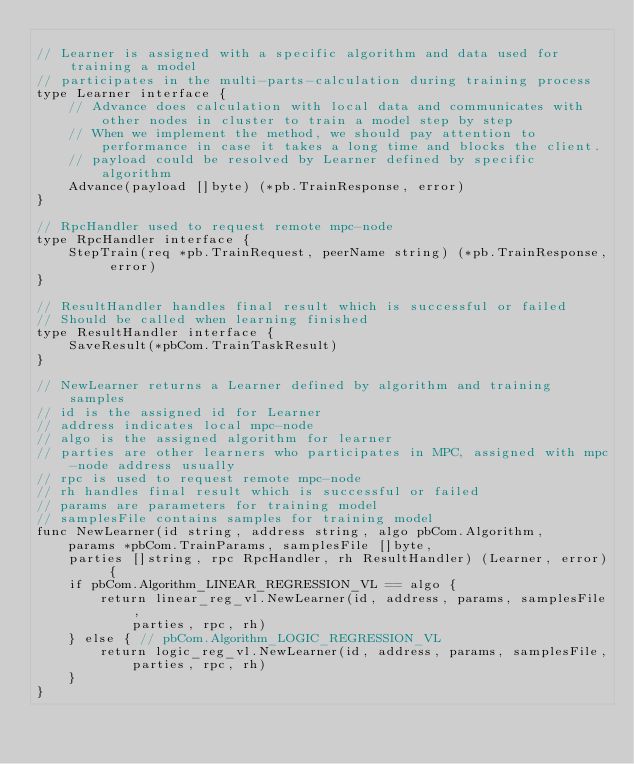<code> <loc_0><loc_0><loc_500><loc_500><_Go_>
// Learner is assigned with a specific algorithm and data used for training a model
// participates in the multi-parts-calculation during training process
type Learner interface {
	// Advance does calculation with local data and communicates with other nodes in cluster to train a model step by step
	// When we implement the method, we should pay attention to performance in case it takes a long time and blocks the client.
	// payload could be resolved by Learner defined by specific algorithm
	Advance(payload []byte) (*pb.TrainResponse, error)
}

// RpcHandler used to request remote mpc-node
type RpcHandler interface {
	StepTrain(req *pb.TrainRequest, peerName string) (*pb.TrainResponse, error)
}

// ResultHandler handles final result which is successful or failed
// Should be called when learning finished
type ResultHandler interface {
	SaveResult(*pbCom.TrainTaskResult)
}

// NewLearner returns a Learner defined by algorithm and training samples
// id is the assigned id for Learner
// address indicates local mpc-node
// algo is the assigned algorithm for learner
// parties are other learners who participates in MPC, assigned with mpc-node address usually
// rpc is used to request remote mpc-node
// rh handles final result which is successful or failed
// params are parameters for training model
// samplesFile contains samples for training model
func NewLearner(id string, address string, algo pbCom.Algorithm,
	params *pbCom.TrainParams, samplesFile []byte,
	parties []string, rpc RpcHandler, rh ResultHandler) (Learner, error) {
	if pbCom.Algorithm_LINEAR_REGRESSION_VL == algo {
		return linear_reg_vl.NewLearner(id, address, params, samplesFile,
			parties, rpc, rh)
	} else { // pbCom.Algorithm_LOGIC_REGRESSION_VL
		return logic_reg_vl.NewLearner(id, address, params, samplesFile,
			parties, rpc, rh)
	}
}
</code> 